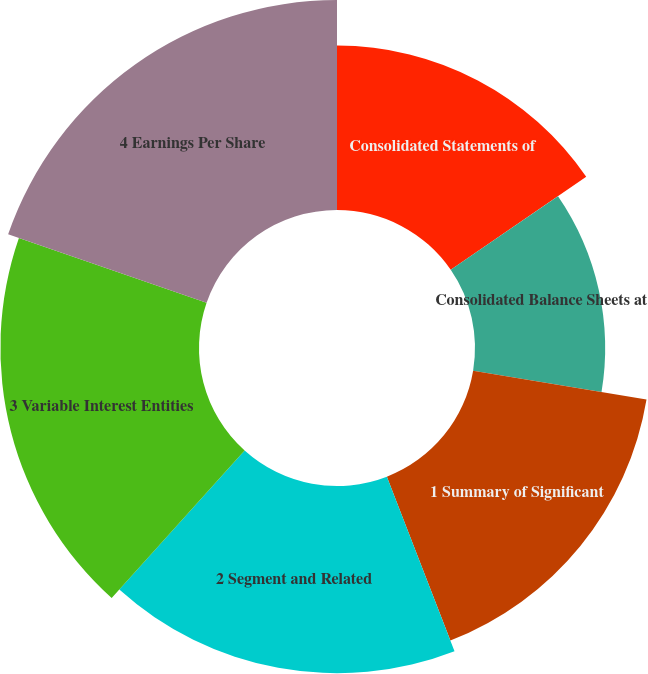Convert chart. <chart><loc_0><loc_0><loc_500><loc_500><pie_chart><fcel>Consolidated Statements of<fcel>Consolidated Balance Sheets at<fcel>1 Summary of Significant<fcel>2 Segment and Related<fcel>3 Variable Interest Entities<fcel>4 Earnings Per Share<nl><fcel>15.42%<fcel>12.21%<fcel>16.49%<fcel>17.56%<fcel>18.63%<fcel>19.7%<nl></chart> 